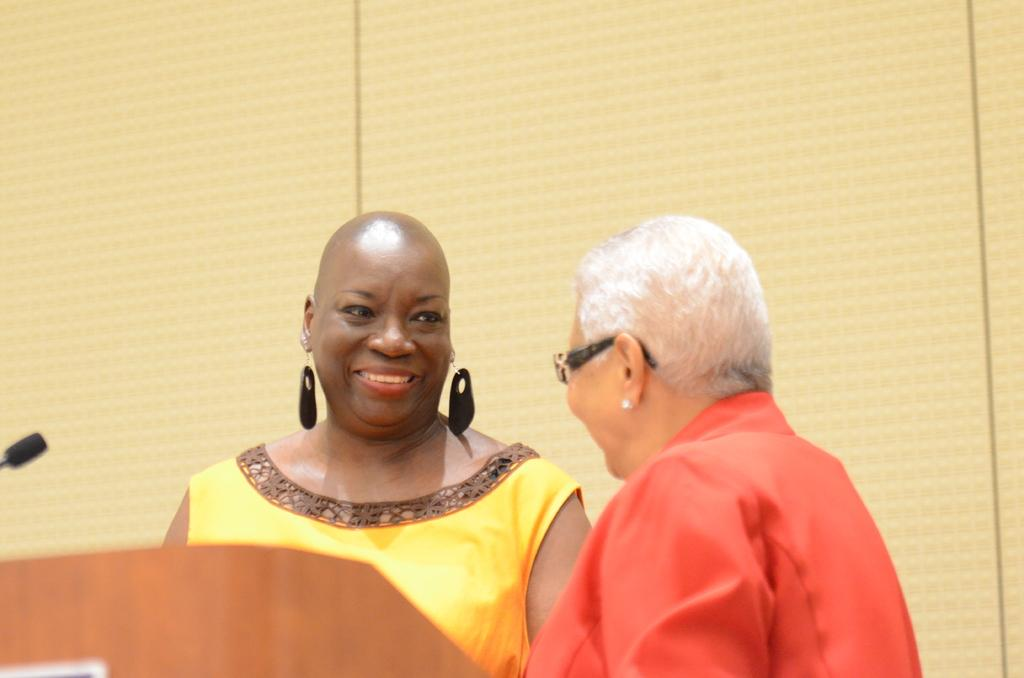Who or what can be seen in the image? There are people in the image. What object is located at the left side of the image? There is a podium at the left side of the image. Can you identify any specific object used for communication in the image? Yes, there is a microphone in the image. What type of theory does the queen regret in the image? There is no queen or any reference to a theory or regret in the image. 